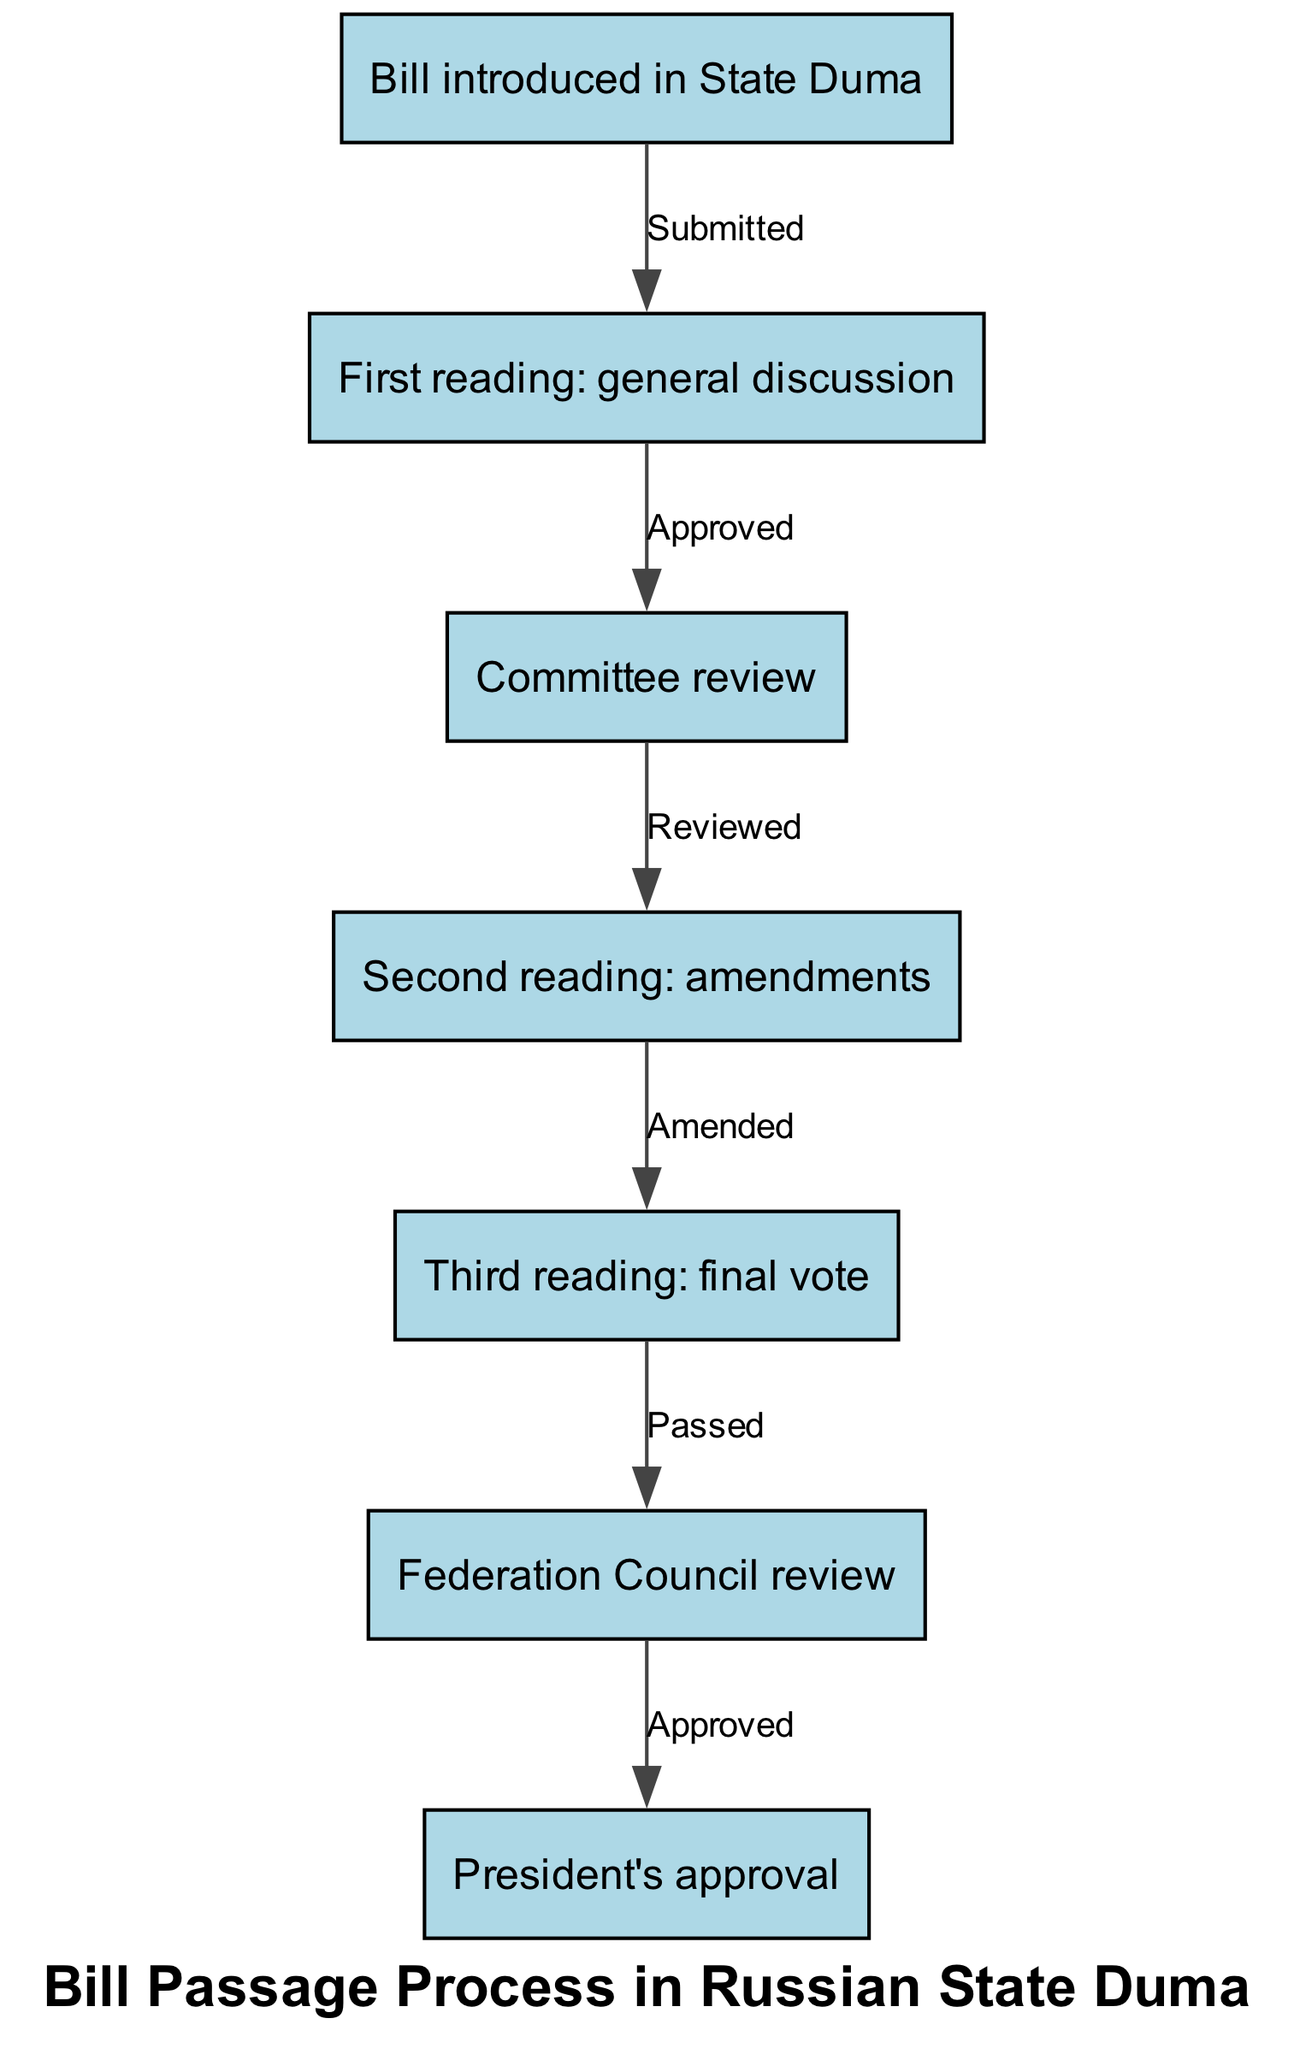What is the first step in the bill passage process? The first step in the process is represented by the first node, which states, "Bill introduced in State Duma."
Answer: Bill introduced in State Duma How many nodes are there in the diagram? The diagram features a total of 7 nodes, each representing a different step in the bill passage process.
Answer: 7 What is the relationship between the first reading and the committee review? The first reading is followed by the committee review, which is indicated by the edge labeled "Approved" connecting the first reading node to the committee review node.
Answer: Approved What happens after the bill is passed by the third reading? After the bill is passed in the third reading, the next step is the Federation Council review, as shown by the edge labeled "Passed."
Answer: Federation Council review How many edges are present in the diagram? There are 6 edges in the diagram, showing the connections and transitions between the various steps in the bill passage process.
Answer: 6 What is the final step in the bill passage process? The final step is depicted in the last node, which states, "President's approval."
Answer: President's approval What label connects the second reading to the third reading? The label connecting the second reading to the third reading is "Amended," indicating that the bill may undergo changes during this phase.
Answer: Amended Which step follows the Federation Council review? The step that follows is the President's approval, demonstrating the final stage of the process after review by the Federation Council.
Answer: President's approval What describes the relationship between the committee review and the second reading? The relationship is described by the edge labeled "Reviewed," indicating that the committee review is a prerequisite for proceeding to the second reading.
Answer: Reviewed 